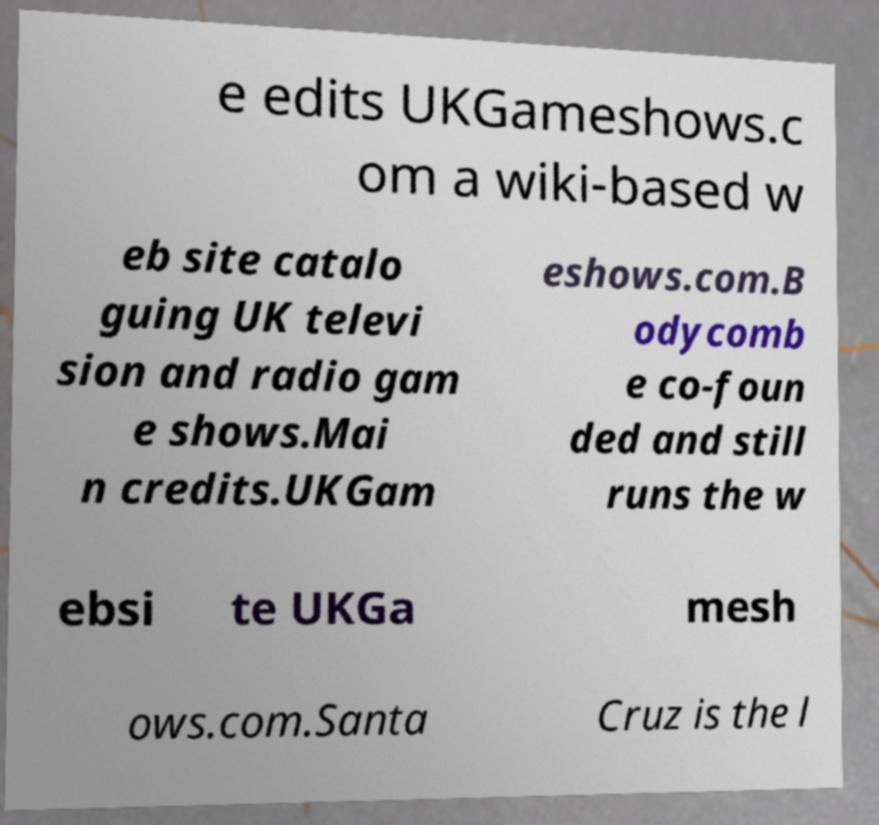Could you extract and type out the text from this image? e edits UKGameshows.c om a wiki-based w eb site catalo guing UK televi sion and radio gam e shows.Mai n credits.UKGam eshows.com.B odycomb e co-foun ded and still runs the w ebsi te UKGa mesh ows.com.Santa Cruz is the l 